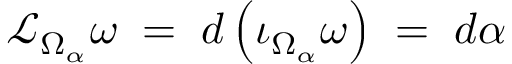<formula> <loc_0><loc_0><loc_500><loc_500>{ \mathcal { L } } _ { \Omega _ { \alpha } } \omega \, = \, d \left ( \iota _ { \Omega _ { \alpha } } \omega \right ) \, = \, d \alpha</formula> 